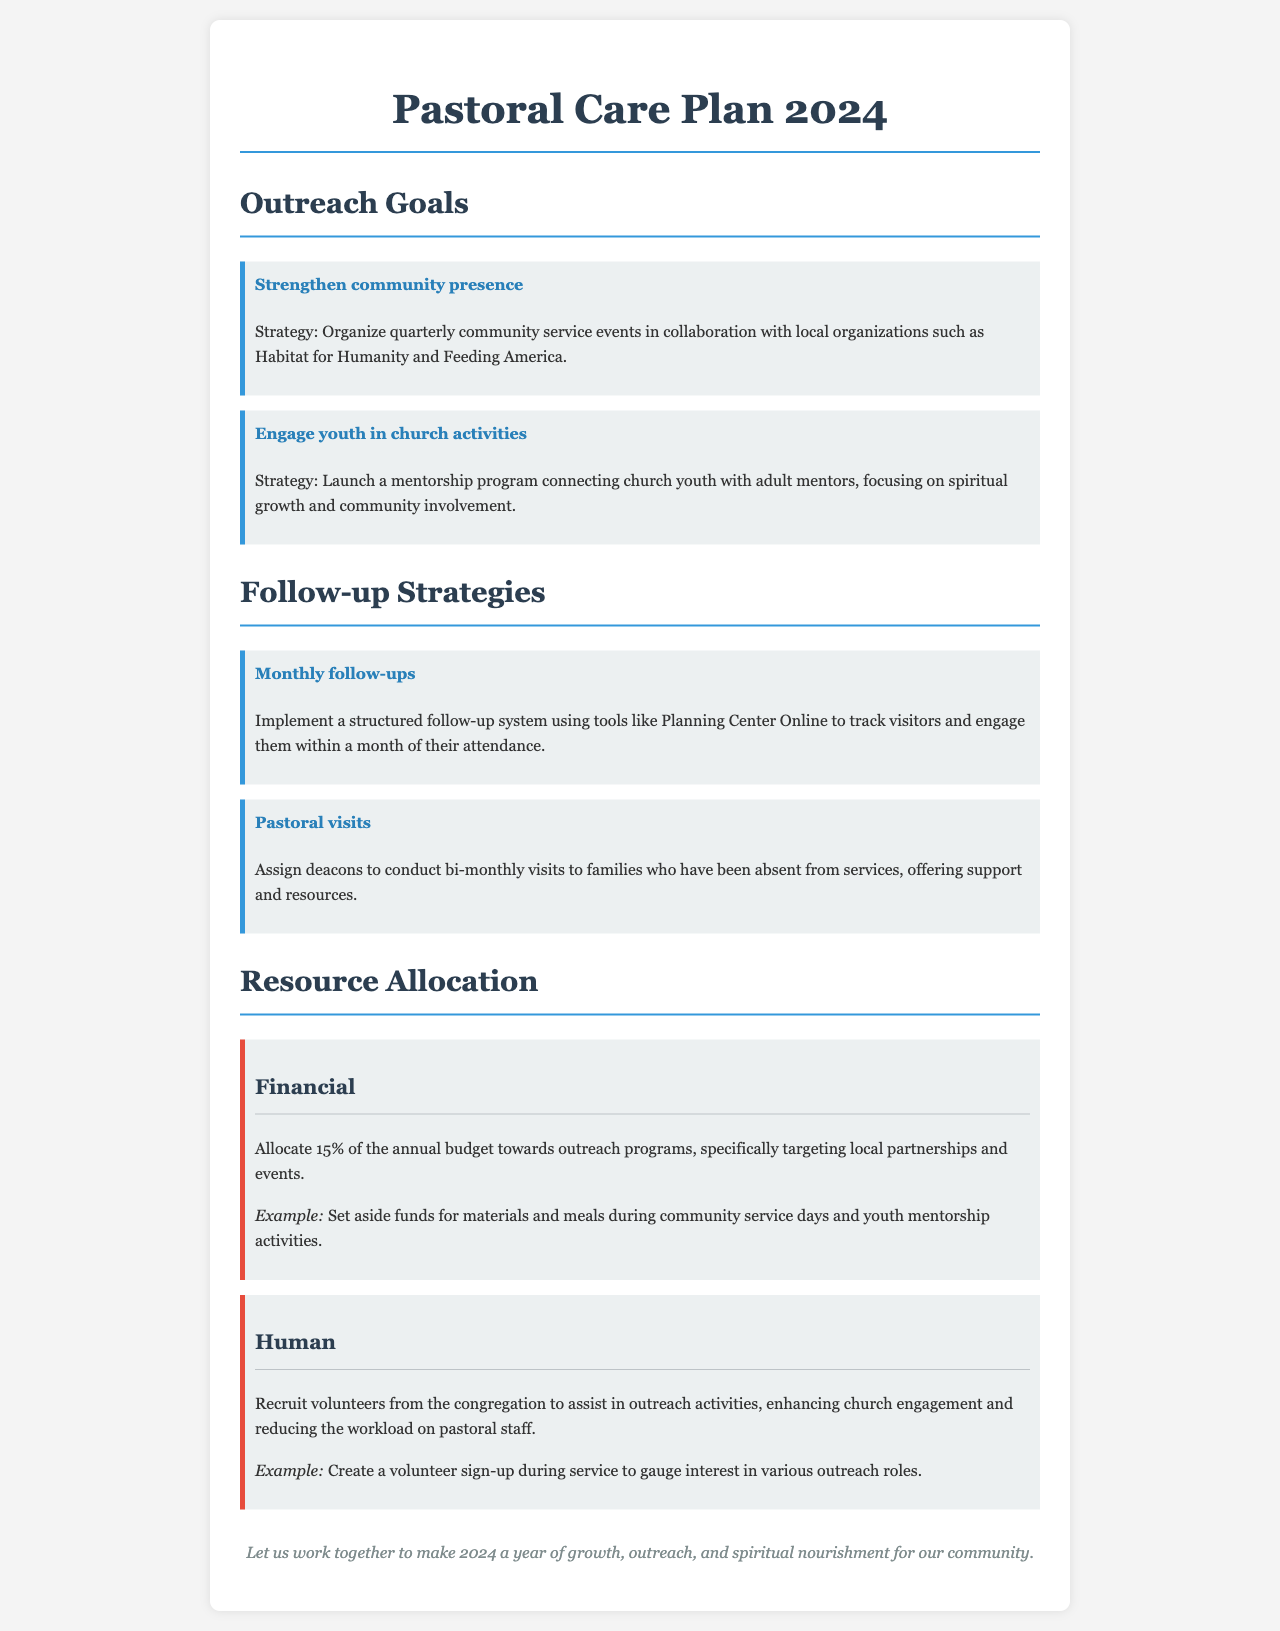What is the title of the document? The title is prominently displayed at the top of the document, indicating the focus of the content.
Answer: Pastoral Care Plan 2024 What percentage of the annual budget is allocated for outreach programs? The document specifies a percentage dedicated to outreach programs within the resource allocation section.
Answer: 15% What is one strategy mentioned for engaging youth in church activities? The strategy describes a specific program aimed at youth involvement detailed under outreach goals.
Answer: Launch a mentorship program How often will deacons conduct visits to absent families? The frequency of visits is outlined as part of the follow-up strategies section of the document.
Answer: Bi-monthly Name one local organization mentioned for community service collaboration. The document lists organizations that will be partnered with for outreach events.
Answer: Habitat for Humanity What type of resource is being recruited from the congregation? The document discusses the involvement of church members in outreach efforts specifically.
Answer: Volunteers What is the goal related to strengthening community presence? The goal is explicitly stated in the outreach section, showing the intention behind community activities.
Answer: Organize quarterly community service events What type of tool is suggested for tracking visitors? The document provides a specific tool that should be utilized for follow-up strategies.
Answer: Planning Center Online 